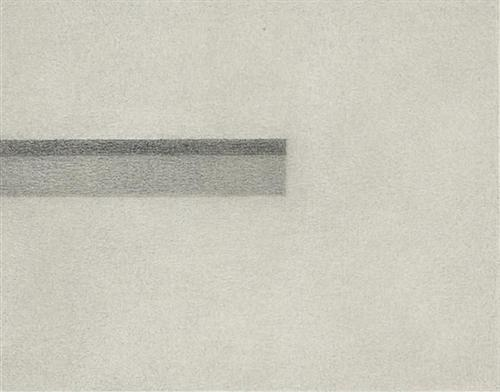Could this artwork represent a specific concept or idea? Yes, the artwork, through its minimalist approach, may symbolize concepts like balance and simplicity. The horizontal line, set against the expansive white space, might represent a horizon—a metaphor for endless possibilities or the division between two elements, such as earth and sky, or reality and the unknown. Does the texture of the line contribute to the overall impact of the artwork? Absolutely, the texture plays a critical role. The slight graininess adds depth and a tactile quality that makes the image more engaging. It prevents the minimalist composition from becoming too sterile, adding warmth and a hint of imperfection that could reflect human emotions or fragility. 